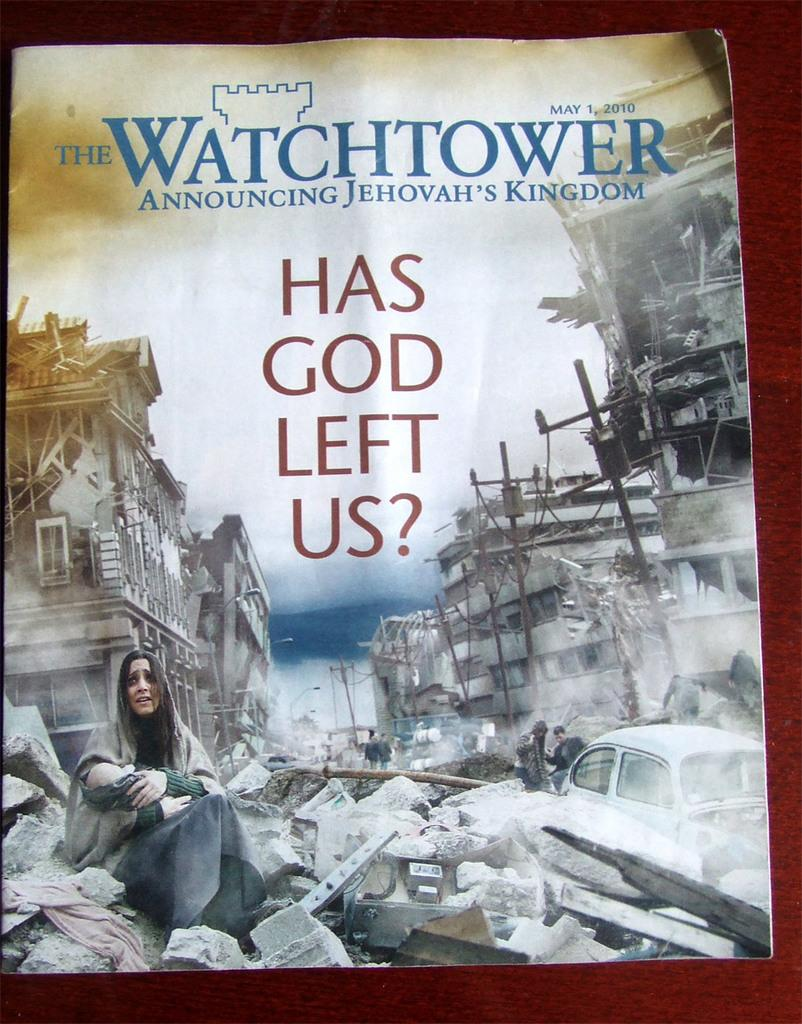<image>
Provide a brief description of the given image. A magazine called The Watch Tower was issued In May 2010. 